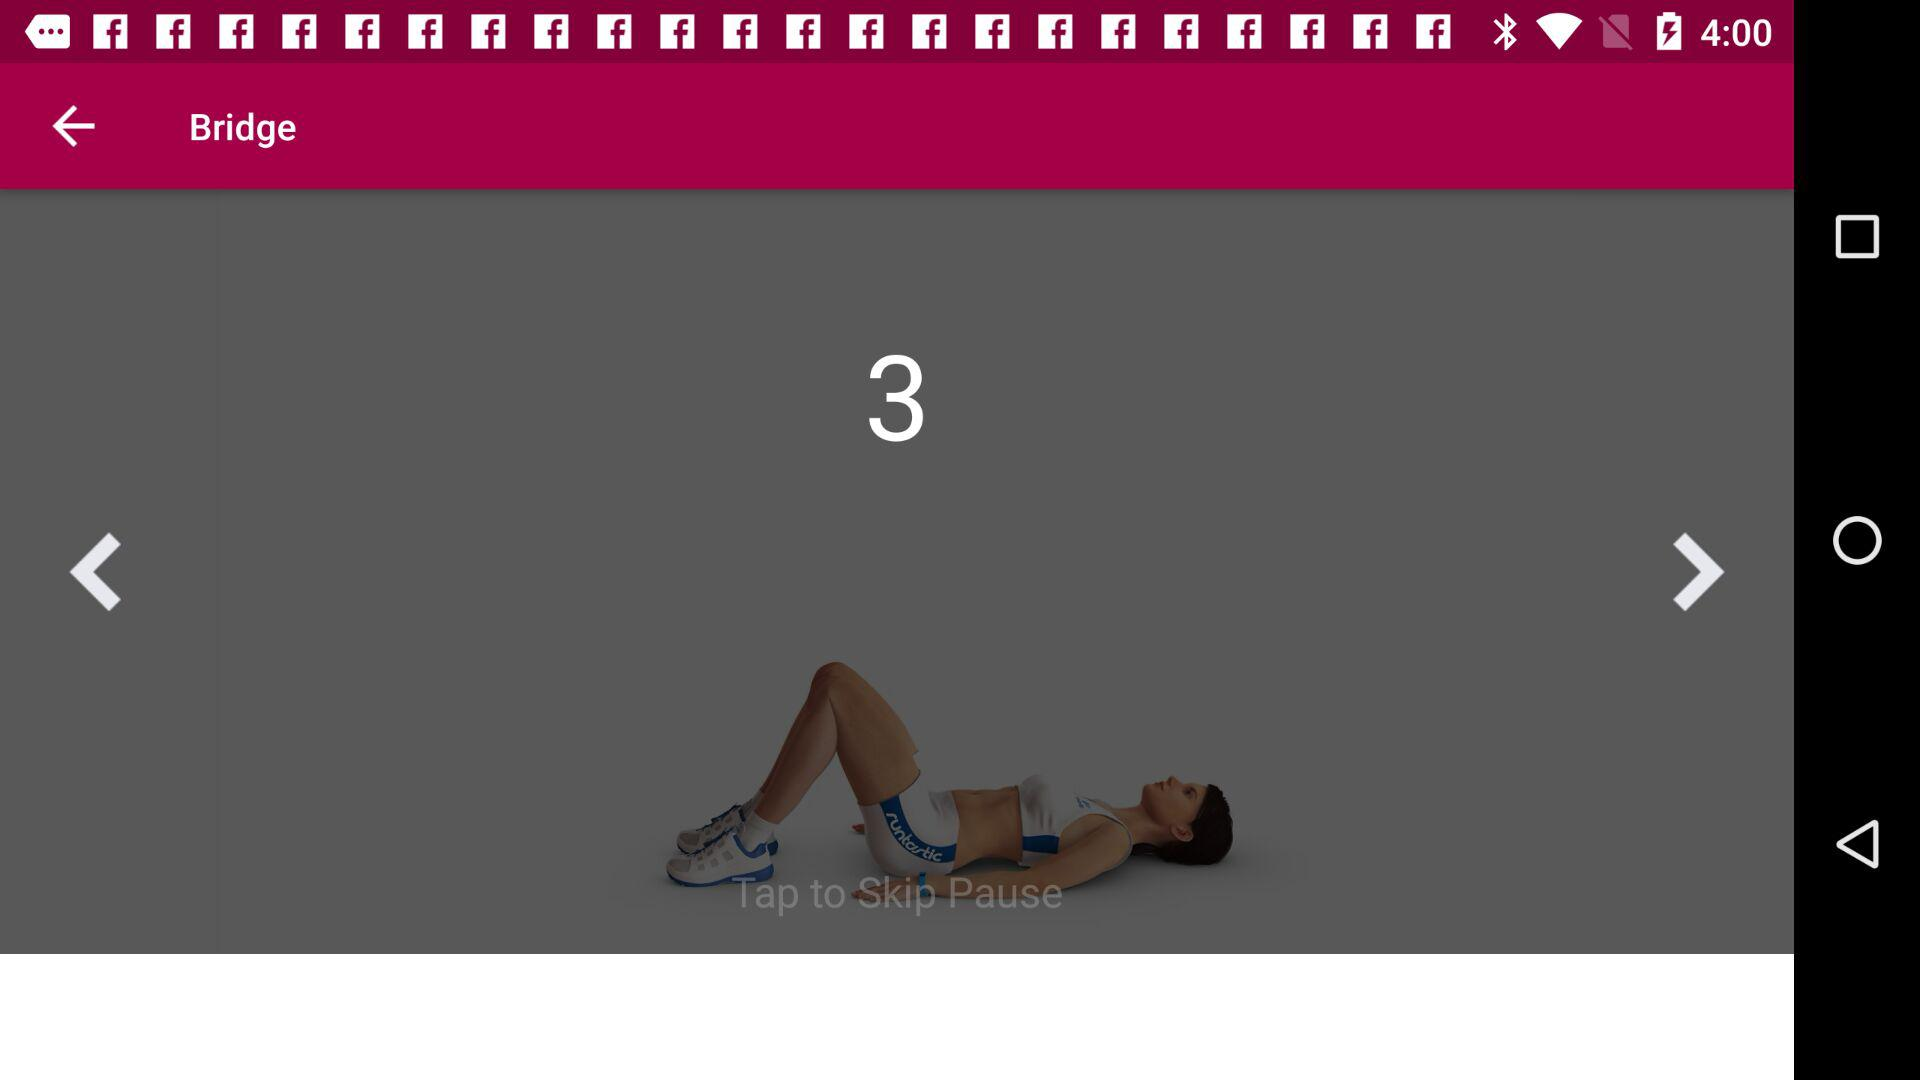What is the application name? The application name is "runtastic". 